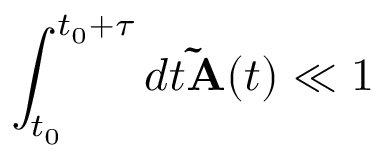<formula> <loc_0><loc_0><loc_500><loc_500>\int _ { t _ { 0 } } ^ { t _ { 0 } + \tau } d t \widetilde { A } ( t ) \ll 1</formula> 